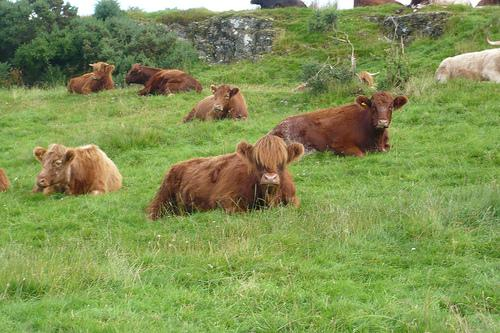Question: how many cows are in the picture?
Choices:
A. Six.
B. Five.
C. Four.
D. Three.
Answer with the letter. Answer: A Question: what are the cows doing?
Choices:
A. Grazing.
B. Sitting.
C. Sleeping.
D. Nursing.
Answer with the letter. Answer: B Question: where are the cows sitting?
Choices:
A. In the barn.
B. In a field.
C. On the hill.
D. By the water.
Answer with the letter. Answer: B 